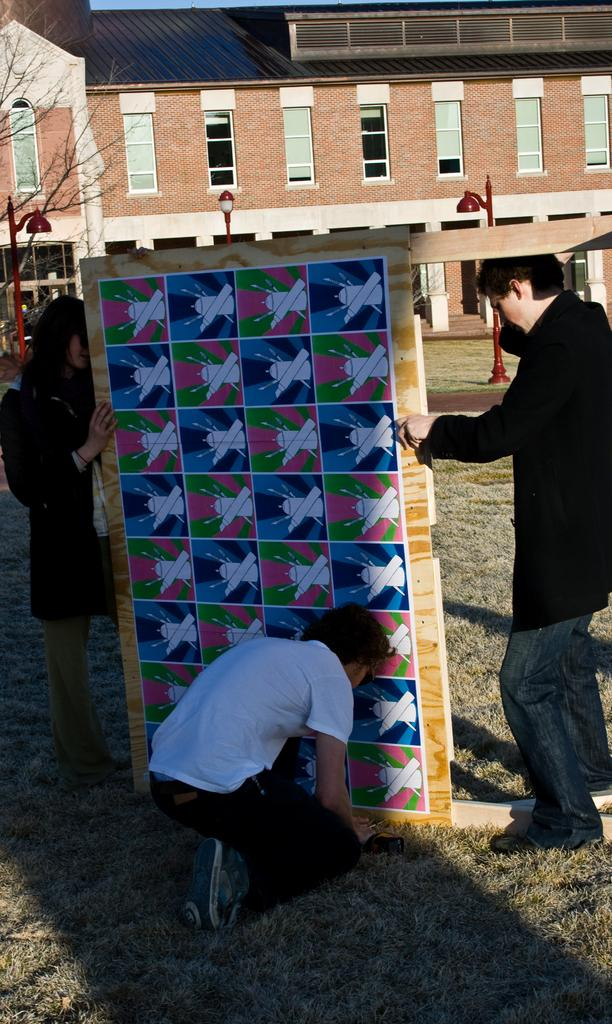What are the persons in the image doing? The persons in the image are standing and holding boards in their hands. What can be seen in the background of the image? There are poles and at least one building in the background of the image. What type of breakfast is being served on the pest in the image? There is no mention of a pest or breakfast in the image; it features persons holding boards and a background with poles and a building. 